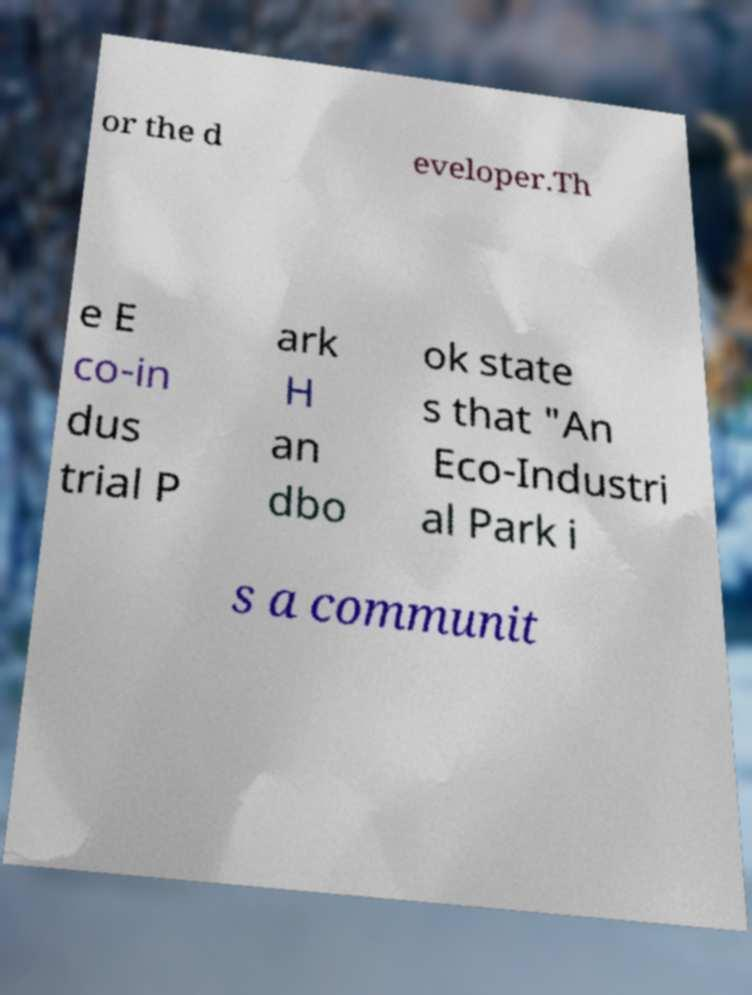I need the written content from this picture converted into text. Can you do that? or the d eveloper.Th e E co-in dus trial P ark H an dbo ok state s that "An Eco-Industri al Park i s a communit 